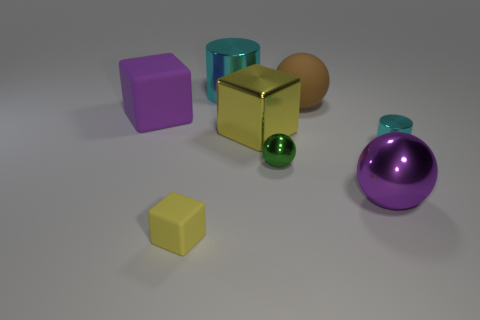Add 6 metallic balls. How many metallic balls are left? 8 Add 7 large purple cubes. How many large purple cubes exist? 8 Add 1 cyan shiny objects. How many objects exist? 9 Subtract all purple blocks. How many blocks are left? 2 Subtract all big purple shiny spheres. How many spheres are left? 2 Subtract 1 cyan cylinders. How many objects are left? 7 Subtract all cylinders. How many objects are left? 6 Subtract 1 balls. How many balls are left? 2 Subtract all green blocks. Subtract all yellow balls. How many blocks are left? 3 Subtract all cyan balls. How many yellow blocks are left? 2 